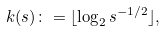<formula> <loc_0><loc_0><loc_500><loc_500>k ( s ) \colon = \lfloor \log _ { 2 } s ^ { - 1 / 2 } \rfloor ,</formula> 